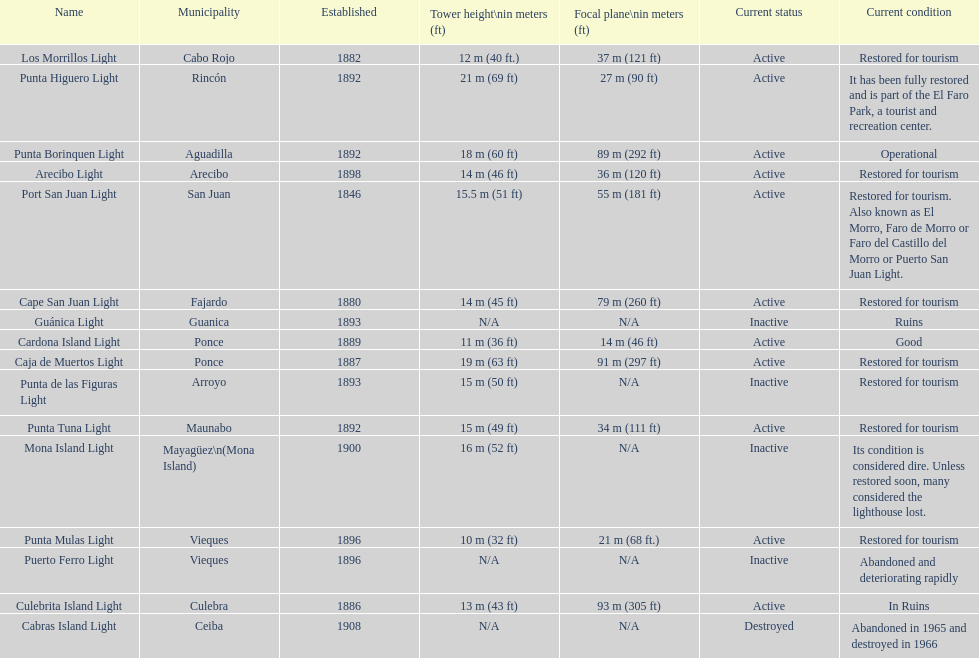Names of municipalities established before 1880 San Juan. 